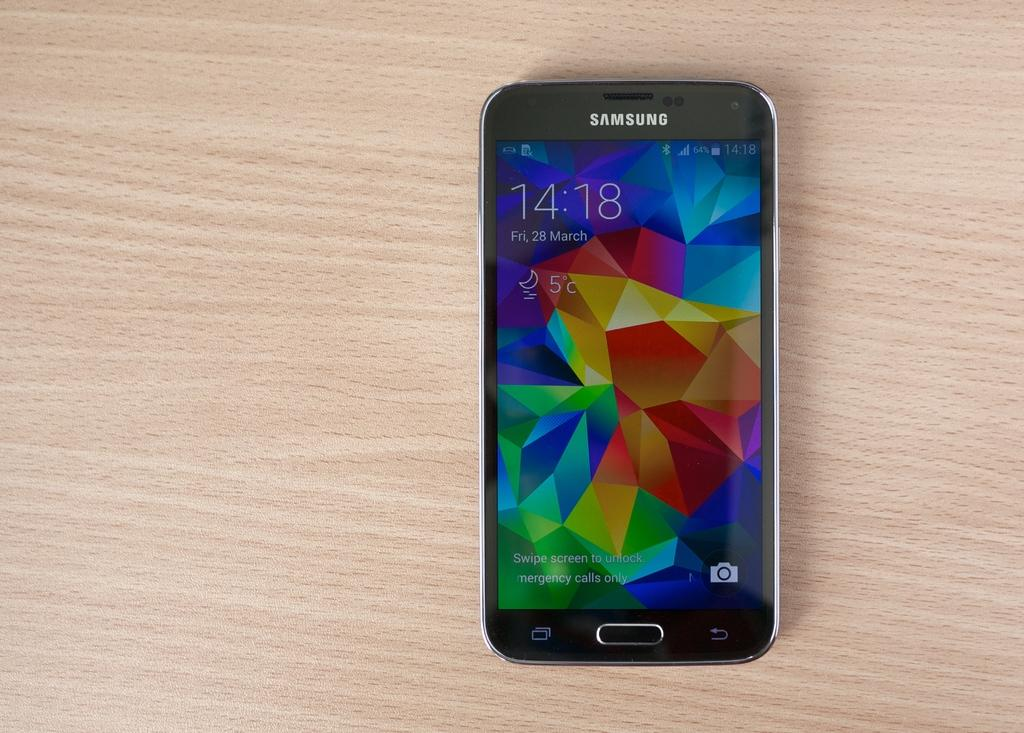<image>
Create a compact narrative representing the image presented. A Samsung phone with a colorful screen sits on a wood table. 